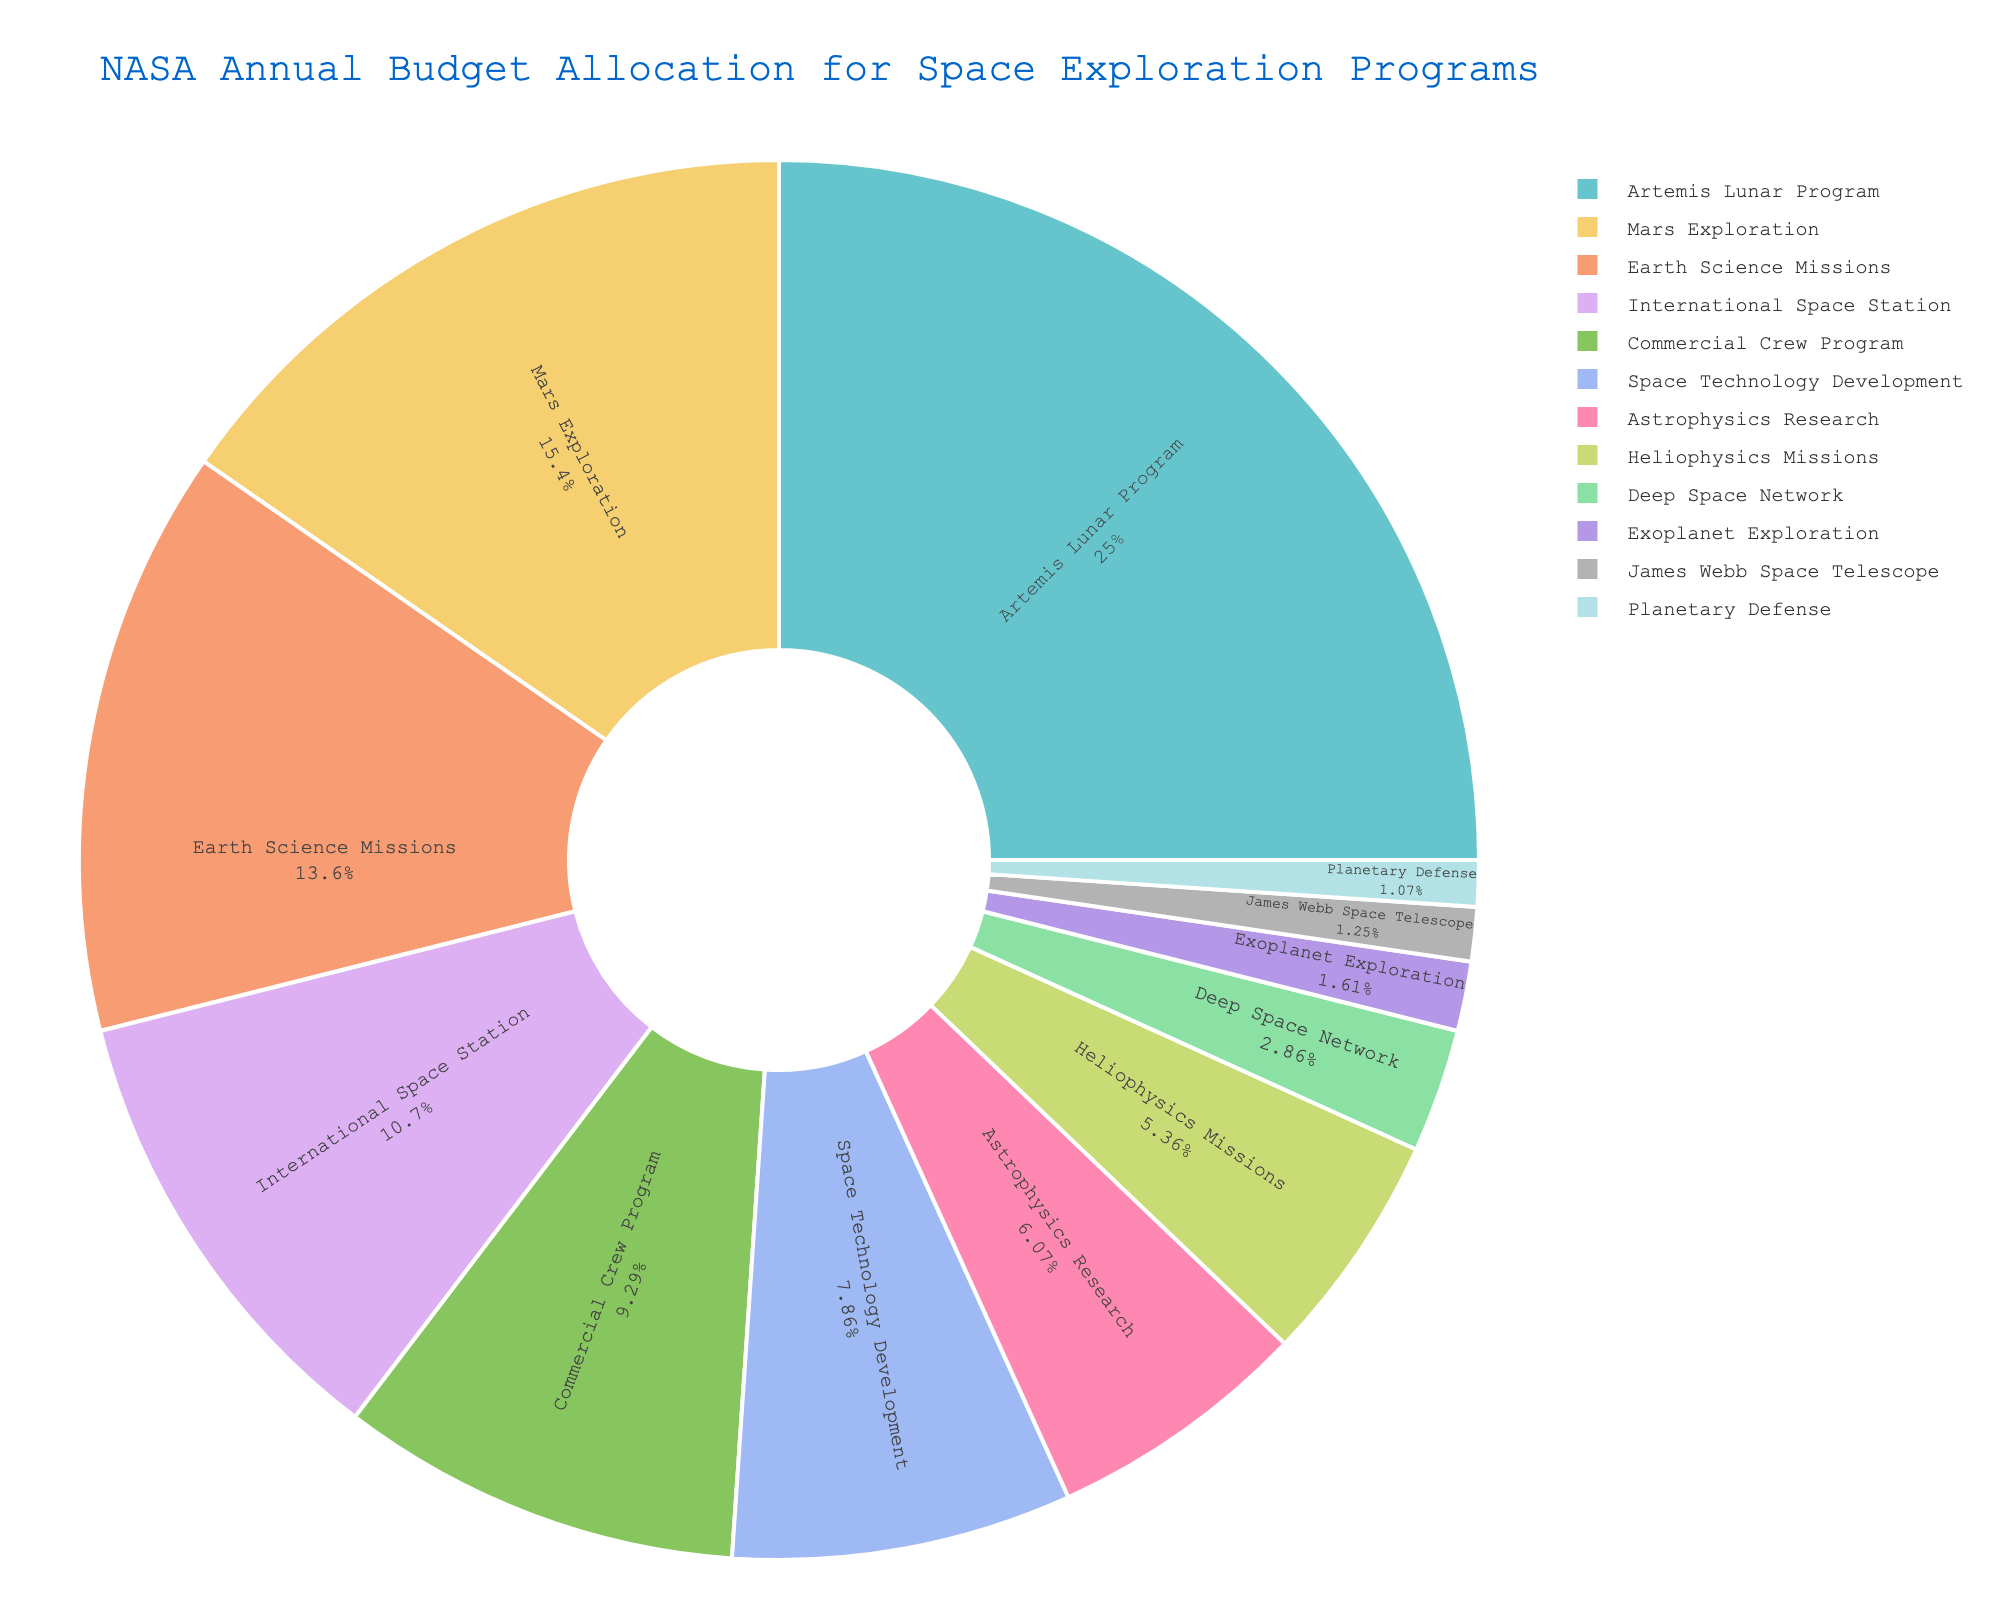Which program received the highest budget allocation? By looking at the pie chart, identify the largest slice which represents the program with the highest budget allocation.
Answer: Artemis Lunar Program What percentage of the budget was allocated to Mars Exploration? Locate the slice labeled "Mars Exploration" and read the percentage value displayed inside it.
Answer: 13% How much more was allocated to the Artemis Lunar Program compared to the Earth Science Missions? Find the budget allocations for the Artemis Lunar Program and Earth Science Missions. Subtract the latter from the former: $3500 million - $1900 million = $1600 million.
Answer: $1600 million Which programs allocated together amount to roughly 30% of the total budget? Identify slices whose sum of percentages is close to 30%. The "Mars Exploration" (13%) and "International Space Station" (10%) combined with "James Webb Space Telescope" (1%) and "Deep Space Network" (2%) produce approximately 30%.
Answer: Mars Exploration, International Space Station, James Webb Space Telescope, Deep Space Network Is the budget for Planetary Defense less than 2% of the total allocation? Locate the slice for Planetary Defense and check its percentage inside the pie chart, which shows 1%.
Answer: Yes Which received a higher budget allocation, Commercial Crew Program or Space Technology Development? Compare the slices for Commercial Crew Program and Space Technology Development. The Commercial Crew Program has a higher allocation at 8% vs. Space Technology Development's 6%.
Answer: Commercial Crew Program Were there any programs allocated exactly $150 million? Look at the slices that mention the budget allocation figures, and find the one matching $150 million. Planetary Defense meets this criterion.
Answer: Yes, Planetary Defense What is the combined allocation for Heliophysics Missions and Exoplanet Exploration? Find the budget values for Heliophysics Missions ($750 million) and Exoplanet Exploration ($225 million). Sum them up: $750 million + $225 million = $975 million.
Answer: $975 million Which program received a lower budget allocation, Astrophysics Research or Deep Space Network? Compare the slices for Astrophysics Research and Deep Space Network. The Deep Space Network has a lower allocation with 2% compared to Astrophysics Research's 5%.
Answer: Deep Space Network Are any two programs receiving an approximately equal budget percentage? Identify any slices with near-equal percentages. The International Space Station (10%) and Commercial Crew Program (9%) are the closest in value.
Answer: Yes, International Space Station and Commercial Crew Program 